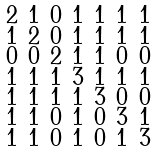<formula> <loc_0><loc_0><loc_500><loc_500>\begin{smallmatrix} 2 & 1 & 0 & 1 & 1 & 1 & 1 \\ 1 & 2 & 0 & 1 & 1 & 1 & 1 \\ 0 & 0 & 2 & 1 & 1 & 0 & 0 \\ 1 & 1 & 1 & 3 & 1 & 1 & 1 \\ 1 & 1 & 1 & 1 & 3 & 0 & 0 \\ 1 & 1 & 0 & 1 & 0 & 3 & 1 \\ 1 & 1 & 0 & 1 & 0 & 1 & 3 \end{smallmatrix}</formula> 